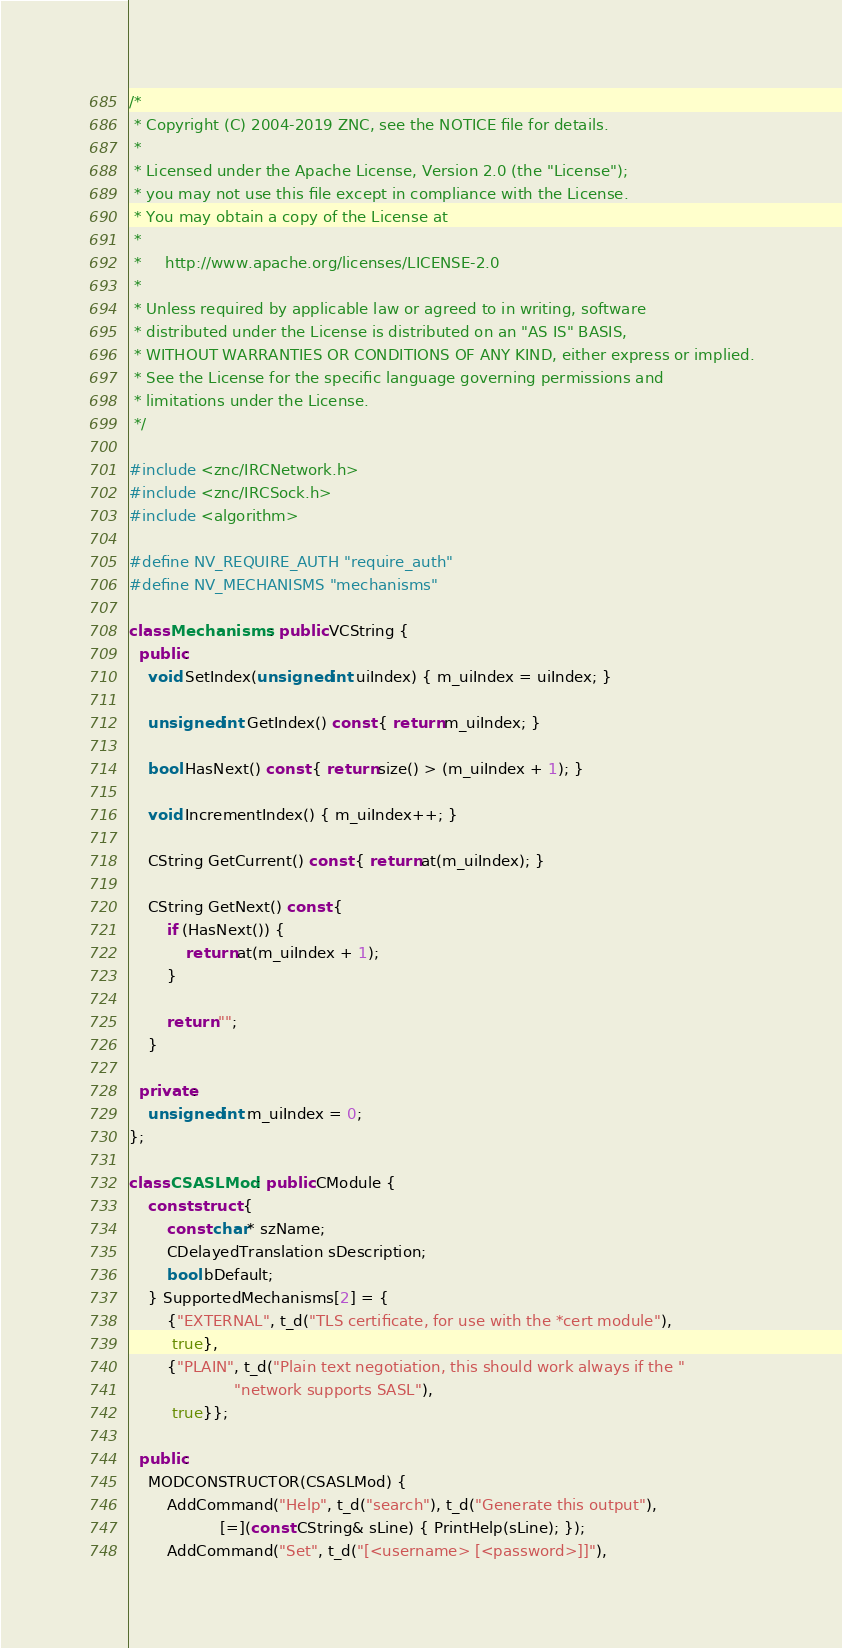<code> <loc_0><loc_0><loc_500><loc_500><_C++_>/*
 * Copyright (C) 2004-2019 ZNC, see the NOTICE file for details.
 *
 * Licensed under the Apache License, Version 2.0 (the "License");
 * you may not use this file except in compliance with the License.
 * You may obtain a copy of the License at
 *
 *     http://www.apache.org/licenses/LICENSE-2.0
 *
 * Unless required by applicable law or agreed to in writing, software
 * distributed under the License is distributed on an "AS IS" BASIS,
 * WITHOUT WARRANTIES OR CONDITIONS OF ANY KIND, either express or implied.
 * See the License for the specific language governing permissions and
 * limitations under the License.
 */

#include <znc/IRCNetwork.h>
#include <znc/IRCSock.h>
#include <algorithm>

#define NV_REQUIRE_AUTH "require_auth"
#define NV_MECHANISMS "mechanisms"

class Mechanisms : public VCString {
  public:
    void SetIndex(unsigned int uiIndex) { m_uiIndex = uiIndex; }

    unsigned int GetIndex() const { return m_uiIndex; }

    bool HasNext() const { return size() > (m_uiIndex + 1); }

    void IncrementIndex() { m_uiIndex++; }

    CString GetCurrent() const { return at(m_uiIndex); }

    CString GetNext() const {
        if (HasNext()) {
            return at(m_uiIndex + 1);
        }

        return "";
    }

  private:
    unsigned int m_uiIndex = 0;
};

class CSASLMod : public CModule {
    const struct {
        const char* szName;
        CDelayedTranslation sDescription;
        bool bDefault;
    } SupportedMechanisms[2] = {
        {"EXTERNAL", t_d("TLS certificate, for use with the *cert module"),
         true},
        {"PLAIN", t_d("Plain text negotiation, this should work always if the "
                      "network supports SASL"),
         true}};

  public:
    MODCONSTRUCTOR(CSASLMod) {
        AddCommand("Help", t_d("search"), t_d("Generate this output"),
                   [=](const CString& sLine) { PrintHelp(sLine); });
        AddCommand("Set", t_d("[<username> [<password>]]"),</code> 